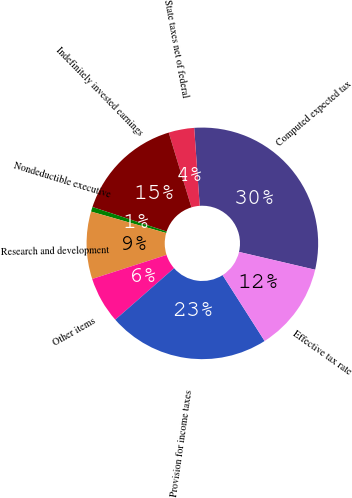Convert chart to OTSL. <chart><loc_0><loc_0><loc_500><loc_500><pie_chart><fcel>Computed expected tax<fcel>State taxes net of federal<fcel>Indefinitely invested earnings<fcel>Nondeductible executive<fcel>Research and development<fcel>Other items<fcel>Provision for income taxes<fcel>Effective tax rate<nl><fcel>29.78%<fcel>3.57%<fcel>15.22%<fcel>0.66%<fcel>9.4%<fcel>6.48%<fcel>22.58%<fcel>12.31%<nl></chart> 